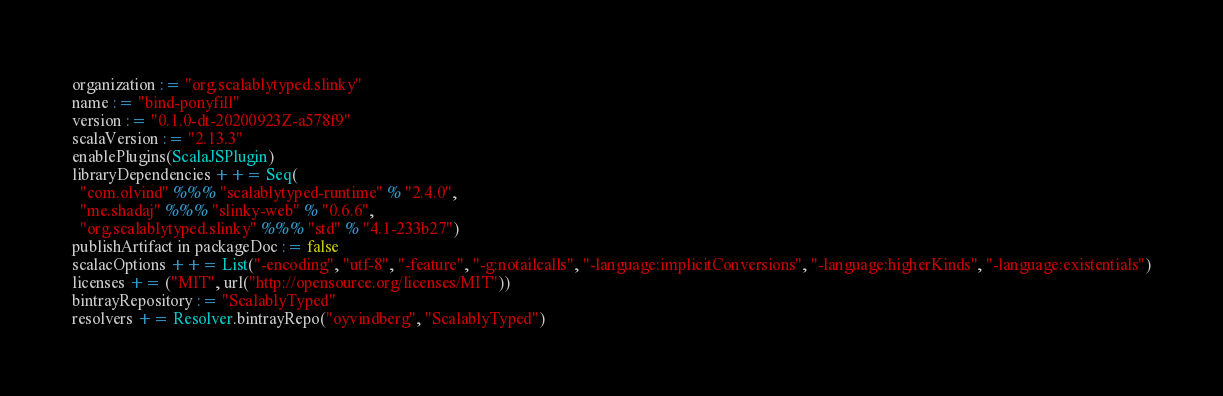<code> <loc_0><loc_0><loc_500><loc_500><_Scala_>organization := "org.scalablytyped.slinky"
name := "bind-ponyfill"
version := "0.1.0-dt-20200923Z-a578f9"
scalaVersion := "2.13.3"
enablePlugins(ScalaJSPlugin)
libraryDependencies ++= Seq(
  "com.olvind" %%% "scalablytyped-runtime" % "2.4.0",
  "me.shadaj" %%% "slinky-web" % "0.6.6",
  "org.scalablytyped.slinky" %%% "std" % "4.1-233b27")
publishArtifact in packageDoc := false
scalacOptions ++= List("-encoding", "utf-8", "-feature", "-g:notailcalls", "-language:implicitConversions", "-language:higherKinds", "-language:existentials")
licenses += ("MIT", url("http://opensource.org/licenses/MIT"))
bintrayRepository := "ScalablyTyped"
resolvers += Resolver.bintrayRepo("oyvindberg", "ScalablyTyped")
</code> 